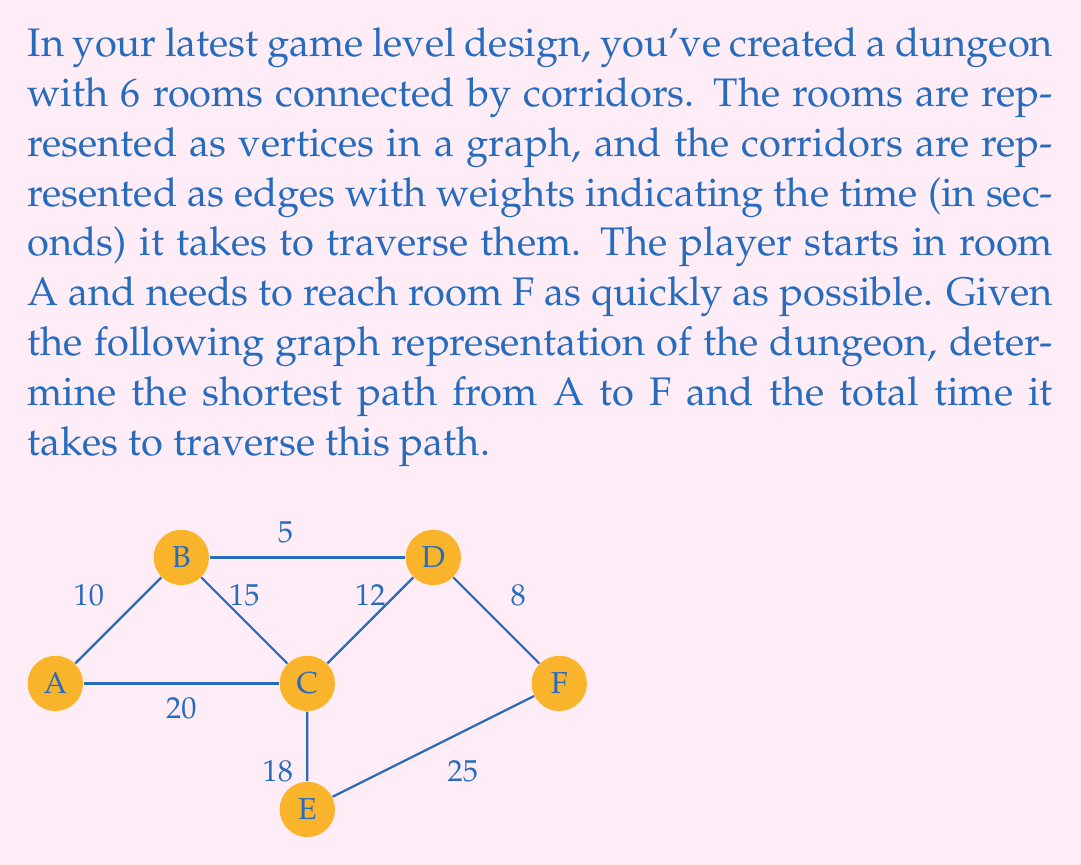Can you answer this question? To solve this problem, we'll use Dijkstra's algorithm, which is an efficient method for finding the shortest path in a weighted graph.

Steps:

1) Initialize:
   - Set distance to A as 0 and all other vertices as infinity.
   - Set all vertices as unvisited.
   - Set A as the current vertex.

2) For the current vertex, consider all unvisited neighbors and calculate their tentative distances.
   - If the calculated distance is less than the previously recorded distance, update it.

3) Mark the current vertex as visited.

4) If the destination vertex (F) has been marked visited, we're done.
   Otherwise, select the unvisited vertex with the smallest tentative distance and set it as the new current vertex. Go back to step 2.

Applying the algorithm:

1) Start at A (distance = 0)
   Update neighbors: B (10), C (20)

2) Visit B (distance = 10)
   Update neighbors: D (15)

3) Visit C (distance = 20)
   Update neighbors: D (32), E (38)

4) Visit D (distance = 15)
   Update neighbors: F (23)

5) Visit F (distance = 23)

The algorithm terminates as we've reached F.

The shortest path is A → B → D → F with a total distance of 23 seconds.

To reconstruct the path, we work backwards:
F was reached from D
D was reached from B
B was reached from A

Therefore, the shortest path is A → B → D → F.
Answer: The shortest path is A → B → D → F, and it takes 23 seconds to traverse. 